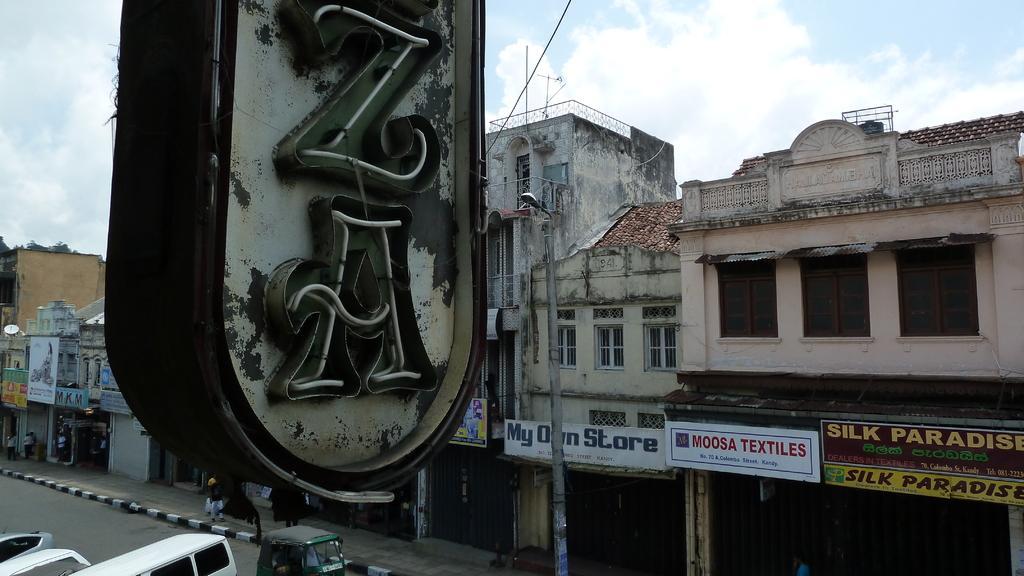Describe this image in one or two sentences. In the foreground of the picture there is a board. At the bottom there are vehicles, road, footpath, street light and people walking on the footpath. In the center of the picture there are buildings, boards and trees. At the top it is sky, sky is cloudy. 